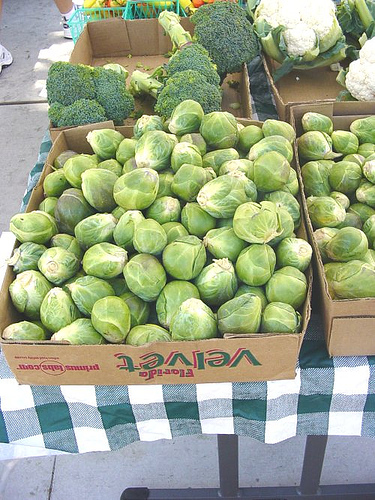Identify and read out the text in this image. Florida velvet 